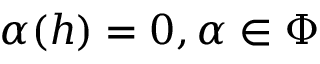<formula> <loc_0><loc_0><loc_500><loc_500>\alpha ( h ) = 0 , \alpha \in \Phi</formula> 